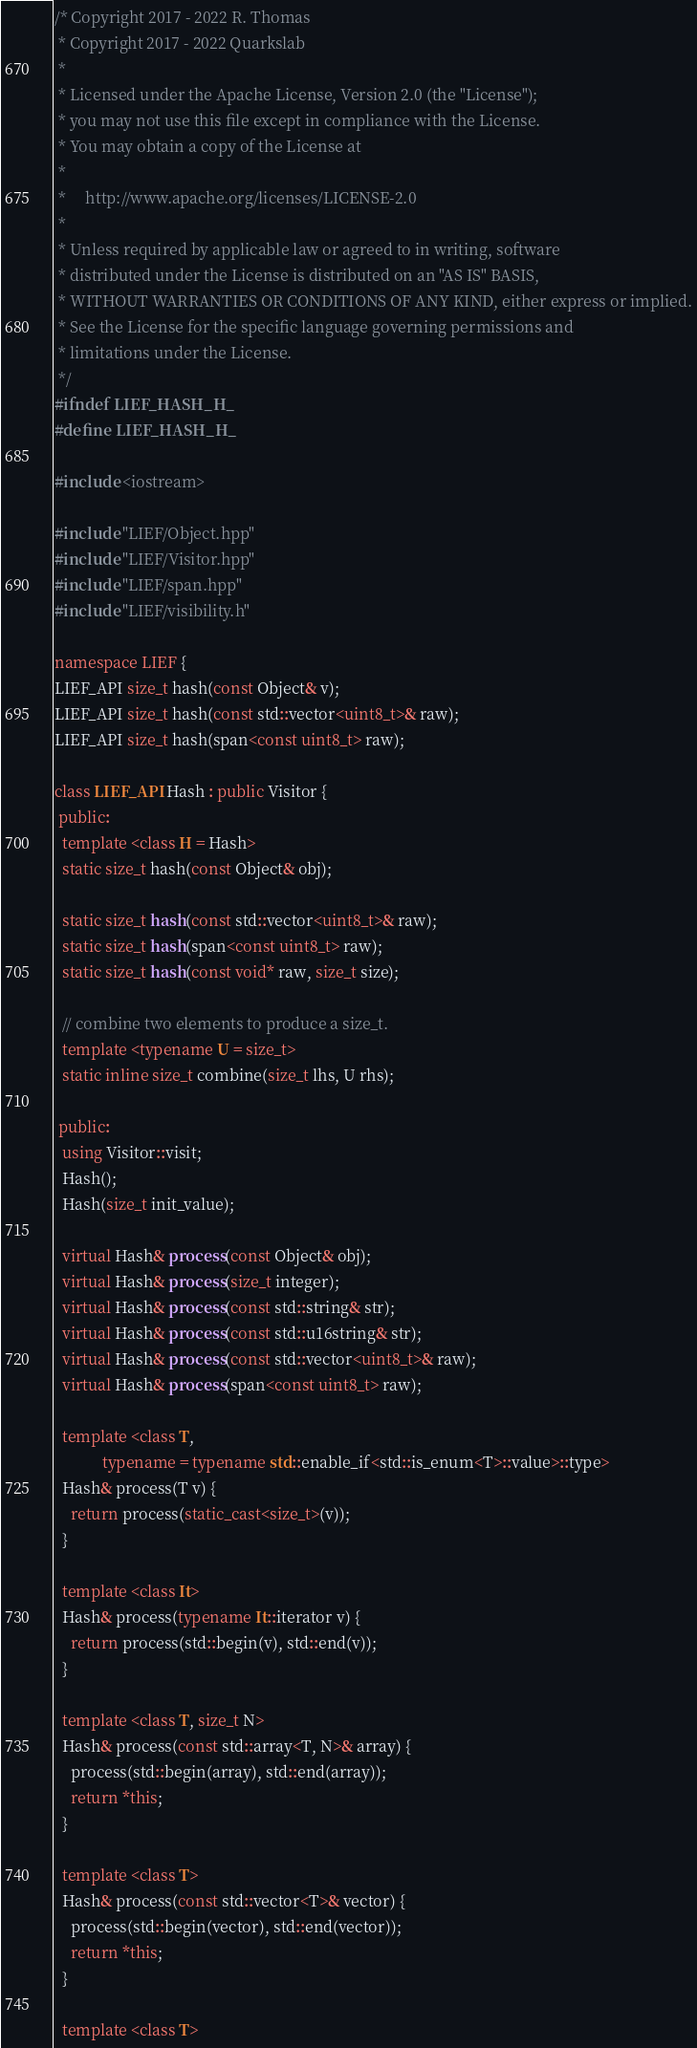<code> <loc_0><loc_0><loc_500><loc_500><_C++_>/* Copyright 2017 - 2022 R. Thomas
 * Copyright 2017 - 2022 Quarkslab
 *
 * Licensed under the Apache License, Version 2.0 (the "License");
 * you may not use this file except in compliance with the License.
 * You may obtain a copy of the License at
 *
 *     http://www.apache.org/licenses/LICENSE-2.0
 *
 * Unless required by applicable law or agreed to in writing, software
 * distributed under the License is distributed on an "AS IS" BASIS,
 * WITHOUT WARRANTIES OR CONDITIONS OF ANY KIND, either express or implied.
 * See the License for the specific language governing permissions and
 * limitations under the License.
 */
#ifndef LIEF_HASH_H_
#define LIEF_HASH_H_

#include <iostream>

#include "LIEF/Object.hpp"
#include "LIEF/Visitor.hpp"
#include "LIEF/span.hpp"
#include "LIEF/visibility.h"

namespace LIEF {
LIEF_API size_t hash(const Object& v);
LIEF_API size_t hash(const std::vector<uint8_t>& raw);
LIEF_API size_t hash(span<const uint8_t> raw);

class LIEF_API Hash : public Visitor {
 public:
  template <class H = Hash>
  static size_t hash(const Object& obj);

  static size_t hash(const std::vector<uint8_t>& raw);
  static size_t hash(span<const uint8_t> raw);
  static size_t hash(const void* raw, size_t size);

  // combine two elements to produce a size_t.
  template <typename U = size_t>
  static inline size_t combine(size_t lhs, U rhs);

 public:
  using Visitor::visit;
  Hash();
  Hash(size_t init_value);

  virtual Hash& process(const Object& obj);
  virtual Hash& process(size_t integer);
  virtual Hash& process(const std::string& str);
  virtual Hash& process(const std::u16string& str);
  virtual Hash& process(const std::vector<uint8_t>& raw);
  virtual Hash& process(span<const uint8_t> raw);

  template <class T,
            typename = typename std::enable_if<std::is_enum<T>::value>::type>
  Hash& process(T v) {
    return process(static_cast<size_t>(v));
  }

  template <class It>
  Hash& process(typename It::iterator v) {
    return process(std::begin(v), std::end(v));
  }

  template <class T, size_t N>
  Hash& process(const std::array<T, N>& array) {
    process(std::begin(array), std::end(array));
    return *this;
  }

  template <class T>
  Hash& process(const std::vector<T>& vector) {
    process(std::begin(vector), std::end(vector));
    return *this;
  }

  template <class T></code> 